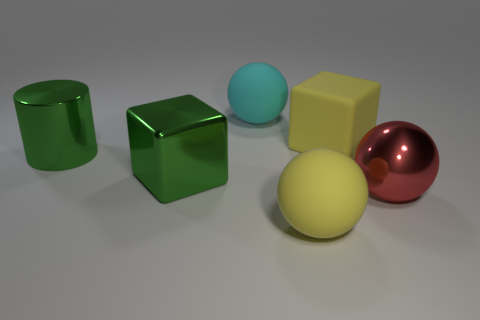There is a ball that is the same color as the rubber block; what is its material?
Offer a terse response. Rubber. Is there any other thing that has the same shape as the red object?
Your answer should be very brief. Yes. What is the material of the block in front of the shiny cylinder?
Ensure brevity in your answer.  Metal. Do the big yellow object that is behind the big green metal cylinder and the big cyan sphere have the same material?
Keep it short and to the point. Yes. What number of objects are either big green metal cylinders or big balls in front of the green cylinder?
Your answer should be very brief. 3. There is a cyan matte thing that is the same shape as the red metal object; what is its size?
Your response must be concise. Large. Are there any green cylinders left of the red metal thing?
Keep it short and to the point. Yes. Is the color of the object in front of the large red metal thing the same as the cube behind the cylinder?
Give a very brief answer. Yes. Are there any big yellow rubber things of the same shape as the large red object?
Provide a succinct answer. Yes. What number of other objects are there of the same color as the large cylinder?
Keep it short and to the point. 1. 